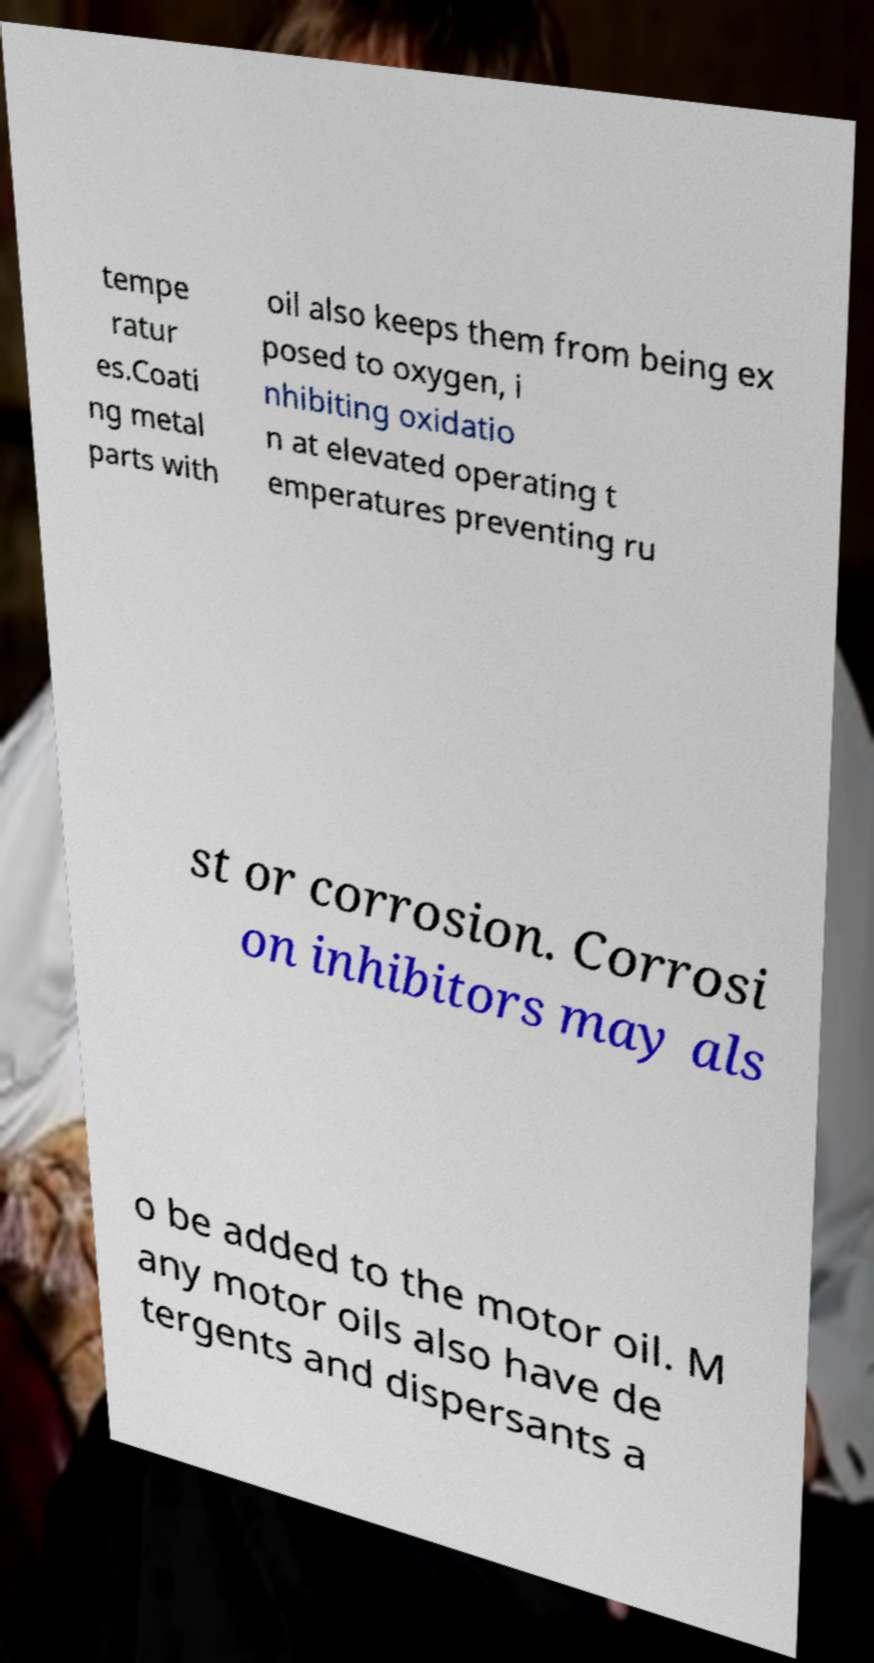Please identify and transcribe the text found in this image. tempe ratur es.Coati ng metal parts with oil also keeps them from being ex posed to oxygen, i nhibiting oxidatio n at elevated operating t emperatures preventing ru st or corrosion. Corrosi on inhibitors may als o be added to the motor oil. M any motor oils also have de tergents and dispersants a 